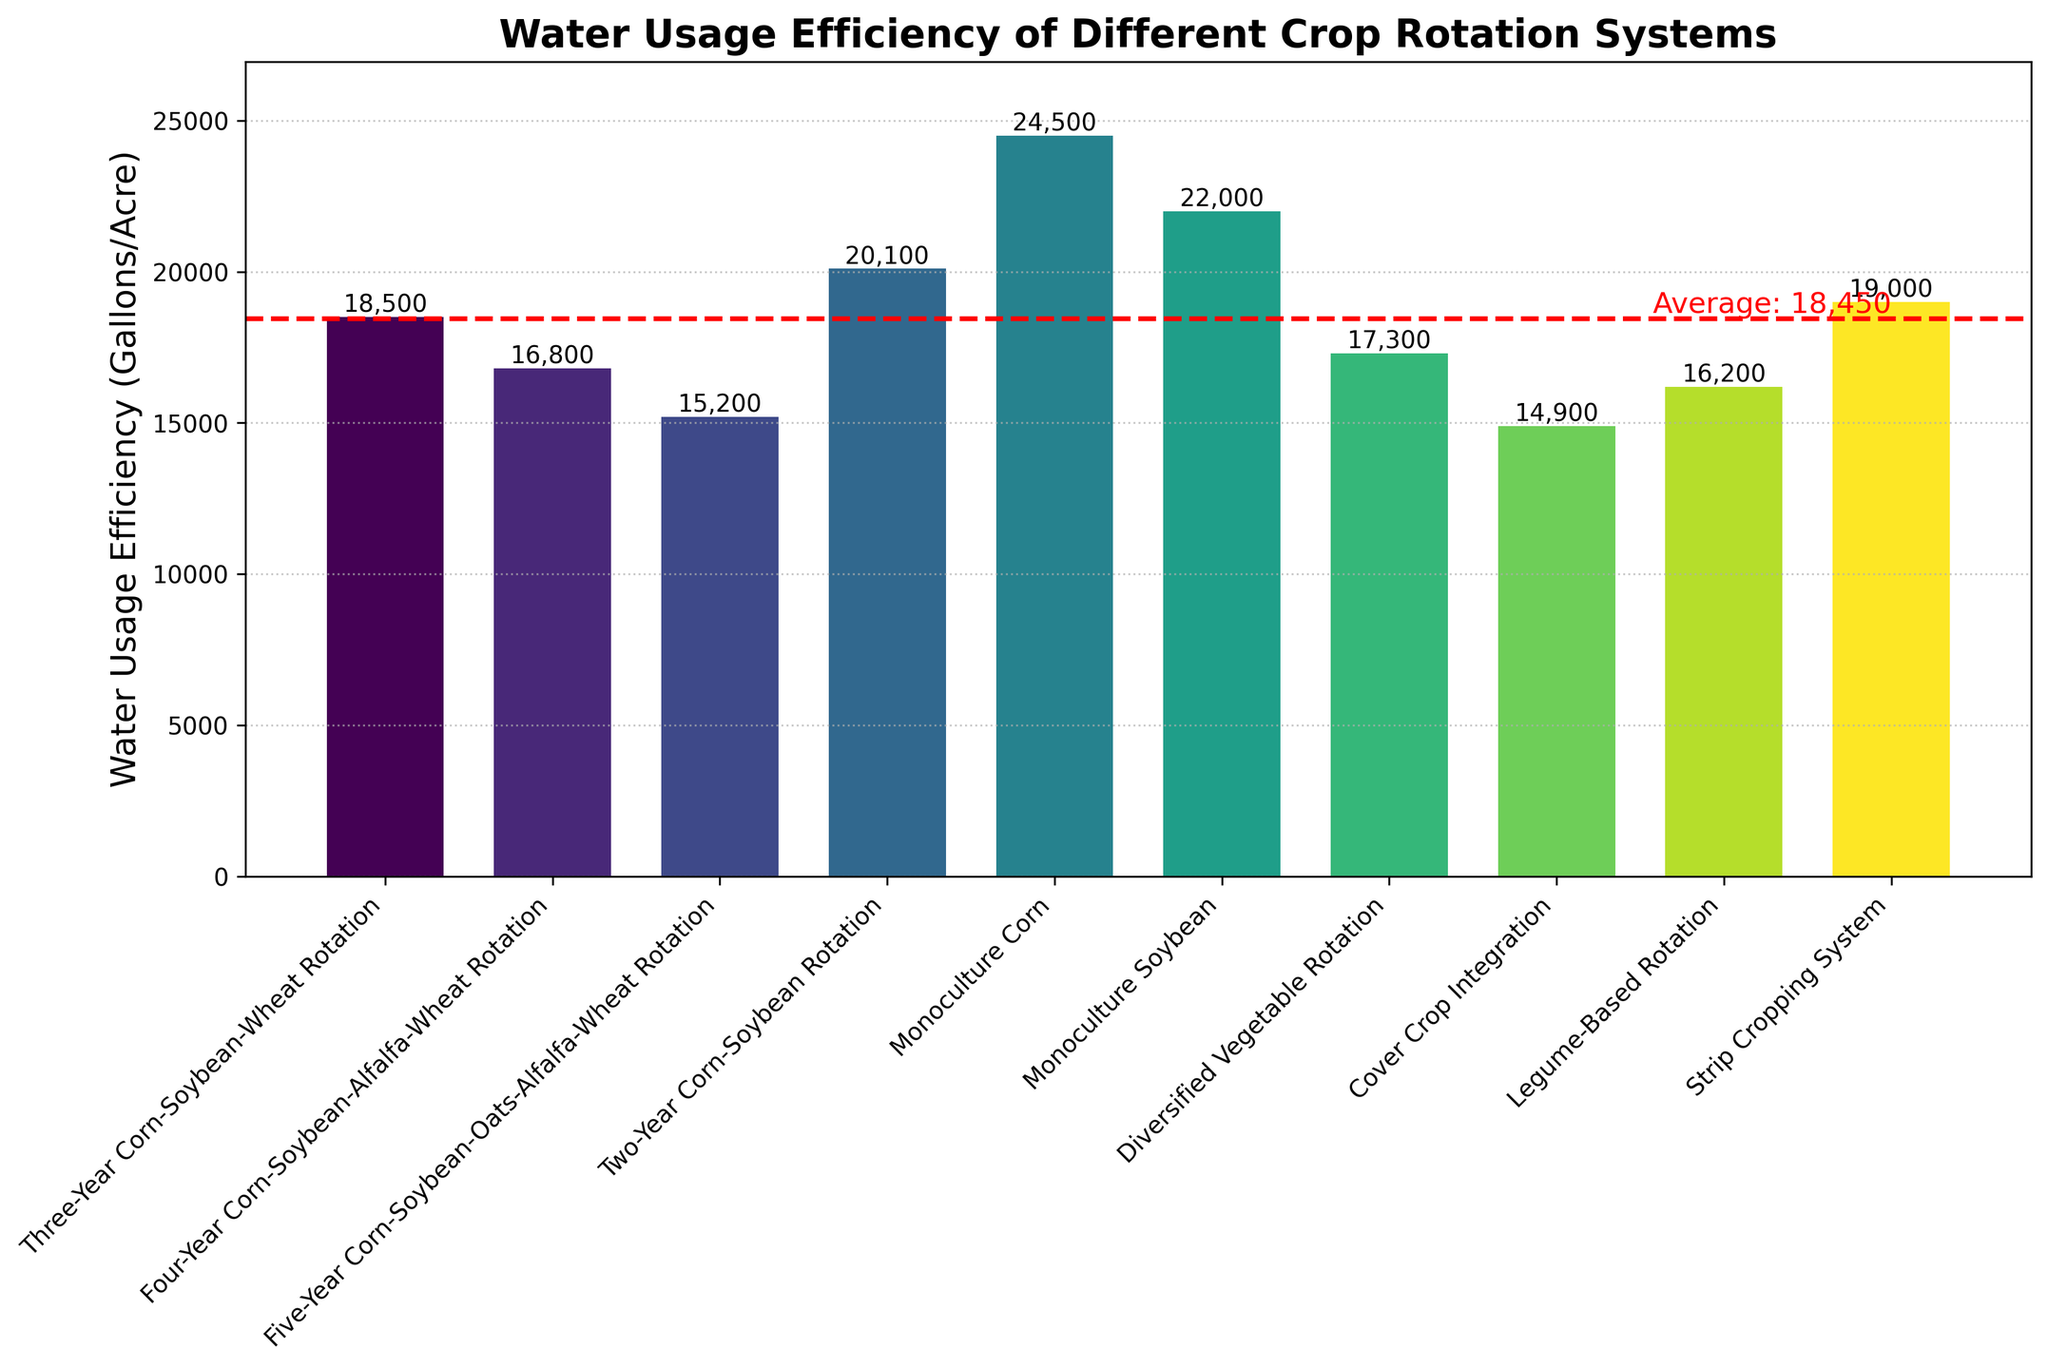Which crop rotation system has the highest water usage efficiency? The highest water usage efficiency is represented by the shortest bar in the plot. The shortest bar corresponds to the "Cover Crop Integration" system with a water usage efficiency of 14,900 gallons per acre.
Answer: Cover Crop Integration Which crop rotation system uses more water, the "Two-Year Corn-Soybean Rotation" or the "Three-Year Corn-Soybean-Wheat Rotation"? By comparing the heights of the bars, the "Two-Year Corn-Soybean Rotation" has a higher bar (20,100 gallons/acre) than the "Three-Year Corn-Soybean-Wheat Rotation" (18,500 gallons/acre).
Answer: Two-Year Corn-Soybean Rotation Which monoculture crop has a higher water usage efficiency? Between "Monoculture Corn" and "Monoculture Soybean," the bar for "Monoculture Soybean" is shorter (22,000 gallons/acre) compared to "Monoculture Corn" (24,500 gallons/acre), indicating higher efficiency.
Answer: Monoculture Soybean What is the average water usage efficiency across all systems? Summing the efficiency values of all systems and dividing by the number of systems: 
(18,500 + 16,800 + 15,200 + 20,100 + 24,500 + 22,000 + 17,300 + 14,900 + 16,200 + 19,000) / 10 = 184,500 / 10 = 18,450 gallons per acre.
Answer: 18,450 Are there any crop rotation systems with water usage efficiency below the average line? The average efficiency line is set at 18,450 gallons/acre. The bars that fall below this line are: "Four-Year Corn-Soybean-Alfalfa-Wheat Rotation" (16,800), "Five-Year Corn-Soybean-Oats-Alfalfa-Wheat Rotation" (15,200), "Diversified Vegetable Rotation" (17,300), "Cover Crop Integration" (14,900), and "Legume-Based Rotation" (16,200).
Answer: Yes Compare the water usage efficiency of "Legume-Based Rotation" to the "Strip Cropping System." Which one is more efficient? The "Legume-Based Rotation" bar (16,200 gallons/acre) is shorter than the "Strip Cropping System" bar (19,000 gallons/acre), indicating that it is more efficient.
Answer: Legume-Based Rotation What is the difference in water usage efficiency between the most efficient system and the least efficient system? The most efficient system is "Cover Crop Integration" (14,900 gallons/acre), and the least efficient is "Monoculture Corn" (24,500 gallons/acre). The difference is 24,500 - 14,900 = 9,600 gallons per acre.
Answer: 9,600 Identify the crop rotation systems with water usage efficiency within 1,000 gallons/acre of the average efficiency. The average efficiency is 18,450 gallons/acre. Crop systems within 1,000 gallons/acre range (17,450 to 19,450) are: "Three-Year Corn-Soybean-Wheat Rotation" (18,500) and "Strip Cropping System" (19,000).
Answer: Three-Year Corn-Soybean-Wheat Rotation, Strip Cropping System How does integrating cover crops affect water usage efficiency compared to the "Four-Year Corn-Soybean-Alfalfa-Wheat Rotation"? The "Cover Crop Integration" (14,900 gallons/acre) has better water efficiency compared to the "Four-Year Corn-Soybean-Alfalfa-Wheat Rotation" (16,800 gallons/acre).
Answer: Better What is the sum of water usage efficiency for all monoculture farming systems? Sum of "Monoculture Corn" (24,500 gallons/acre) and "Monoculture Soybean" (22,000 gallons/acre) is: 24,500 + 22,000 = 46,500 gallons per acre.
Answer: 46,500 